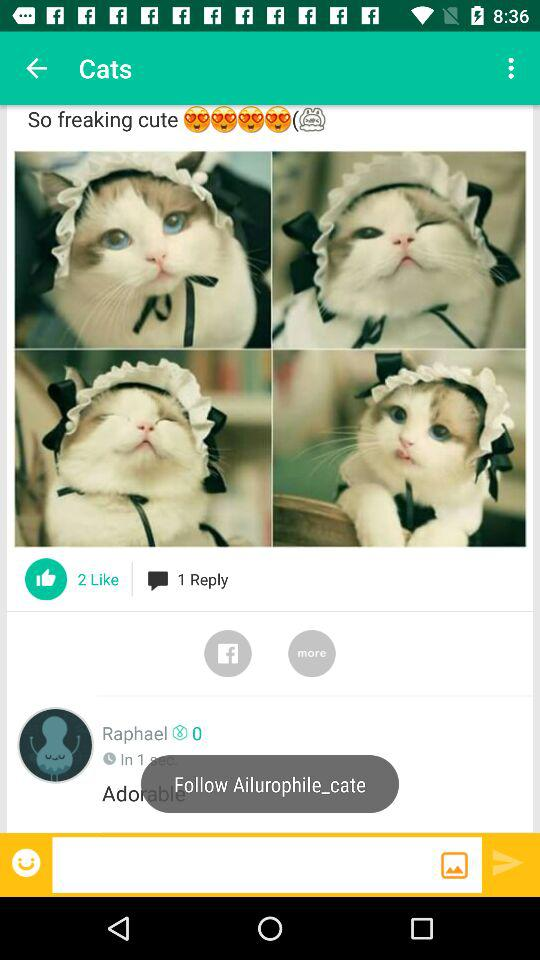How many likes does the post have?
Answer the question using a single word or phrase. 2 